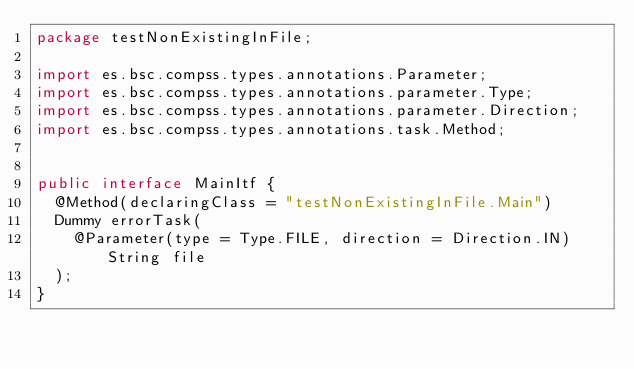Convert code to text. <code><loc_0><loc_0><loc_500><loc_500><_Java_>package testNonExistingInFile;

import es.bsc.compss.types.annotations.Parameter;
import es.bsc.compss.types.annotations.parameter.Type;
import es.bsc.compss.types.annotations.parameter.Direction;
import es.bsc.compss.types.annotations.task.Method;


public interface MainItf {
	@Method(declaringClass = "testNonExistingInFile.Main")
	Dummy errorTask(
		@Parameter(type = Type.FILE, direction = Direction.IN) String file
	);
}
</code> 